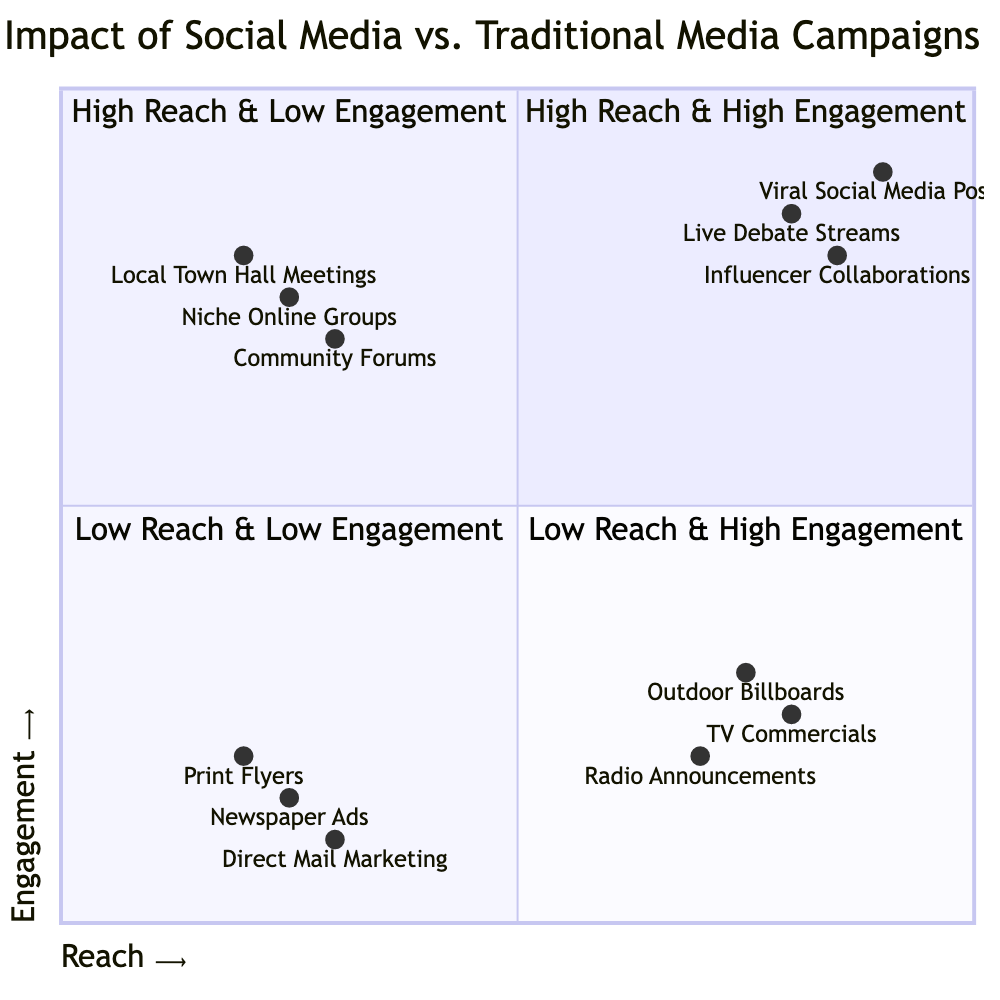What elements are found in the "High Reach & High Engagement" quadrant? The "High Reach & High Engagement" quadrant includes the elements "Viral Social Media Posts," "Live Debate Streams," and "Influencer Collaborations," which are listed directly in that quadrant.
Answer: Viral Social Media Posts, Live Debate Streams, Influencer Collaborations Which campaign type has the lowest engagement but high reach? The "High Reach & Low Engagement" quadrant contains campaign types that have high reach but low engagement, specifically including "Outdoor Billboards," "TV Commercials," and "Radio Announcements." Thus, any of these can be considered, but selecting one of them suffices for the answer.
Answer: Outdoor Billboards How many elements are in the "Low Reach & Low Engagement" quadrant? In the "Low Reach & Low Engagement" quadrant, there are three elements: "Print Flyers," "Newspaper Ads," and "Direct Mail Marketing." Therefore, counting these gives a total of three elements.
Answer: 3 What is the engagement level of "Niche Online Groups"? Looking at the quadrant chart, "Niche Online Groups" is located in the "Low Reach & High Engagement" quadrant with an engagement value of 0.75. As it's stated explicitly in the chart, the engagement level is easily obtained.
Answer: 0.75 Which campaign type has the lowest reach? Within the diagram, "Local Town Hall Meetings" is positioned in the "Low Reach & High Engagement" quadrant with a reach value of 0.2, indicating it has the lowest reach compared to all other campaign types presented.
Answer: Local Town Hall Meetings Which quadrant has the most campaign types listed? Upon review of the quadrants, the "High Reach & High Engagement" quadrant contains three campaign types, as do the "Low Reach & Low Engagement" and "Low Reach & High Engagement" quadrants, while the "High Reach & Low Engagement" quadrant also has three types. However, all quadrants have a tie in terms of the number of elements.
Answer: 4 Quadrants tie with 3 each What are the engagement values of "TV Commercials"? The "TV Commercials" campaign type is located in the "High Reach & Low Engagement" quadrant with an engagement value explicitly listed as 0.25, which means this indicates how interactive or participatory this campaign type is perceived as the level of engagement is rather low.
Answer: 0.25 Which quadrant contains the campaign type with the highest engagement? The campaign type with the highest engagement is "Viral Social Media Posts," which is situated in the "High Reach & High Engagement" quadrant. This positioning shows that it not only reaches a broad audience but also engages that audience effectively.
Answer: High Reach & High Engagement 